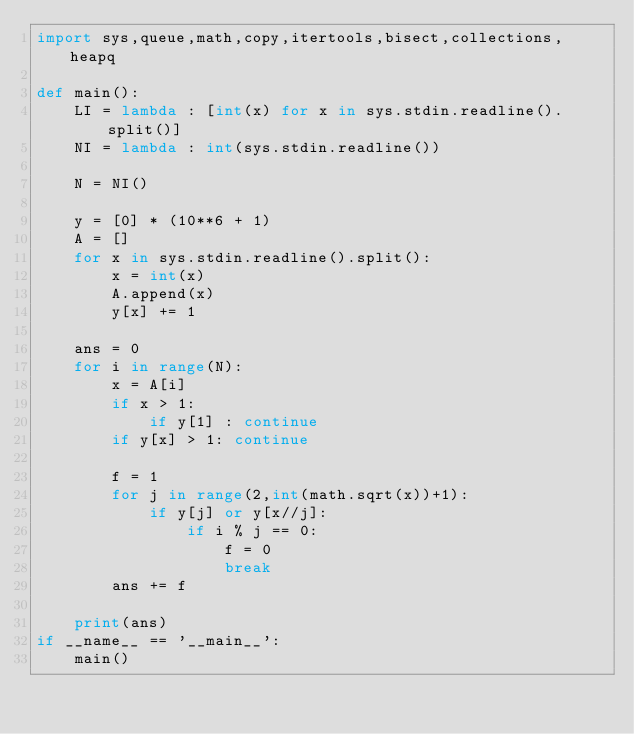<code> <loc_0><loc_0><loc_500><loc_500><_Python_>import sys,queue,math,copy,itertools,bisect,collections,heapq

def main():
    LI = lambda : [int(x) for x in sys.stdin.readline().split()]
    NI = lambda : int(sys.stdin.readline())

    N = NI()

    y = [0] * (10**6 + 1)
    A = []
    for x in sys.stdin.readline().split():
        x = int(x)
        A.append(x)
        y[x] += 1

    ans = 0
    for i in range(N):
        x = A[i]
        if x > 1:
            if y[1] : continue
        if y[x] > 1: continue

        f = 1
        for j in range(2,int(math.sqrt(x))+1):
            if y[j] or y[x//j]:
                if i % j == 0:
                    f = 0
                    break
        ans += f

    print(ans)
if __name__ == '__main__':
    main()
</code> 